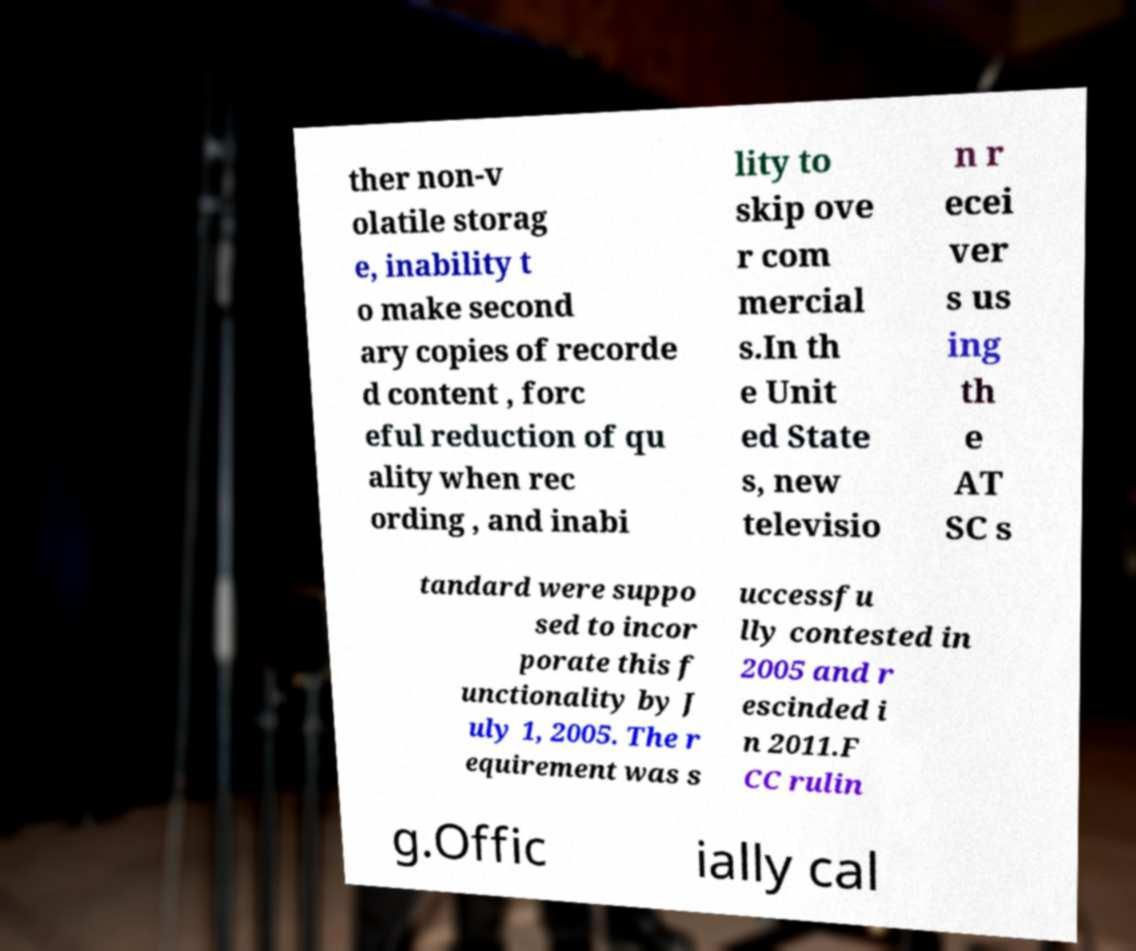Can you read and provide the text displayed in the image?This photo seems to have some interesting text. Can you extract and type it out for me? ther non-v olatile storag e, inability t o make second ary copies of recorde d content , forc eful reduction of qu ality when rec ording , and inabi lity to skip ove r com mercial s.In th e Unit ed State s, new televisio n r ecei ver s us ing th e AT SC s tandard were suppo sed to incor porate this f unctionality by J uly 1, 2005. The r equirement was s uccessfu lly contested in 2005 and r escinded i n 2011.F CC rulin g.Offic ially cal 